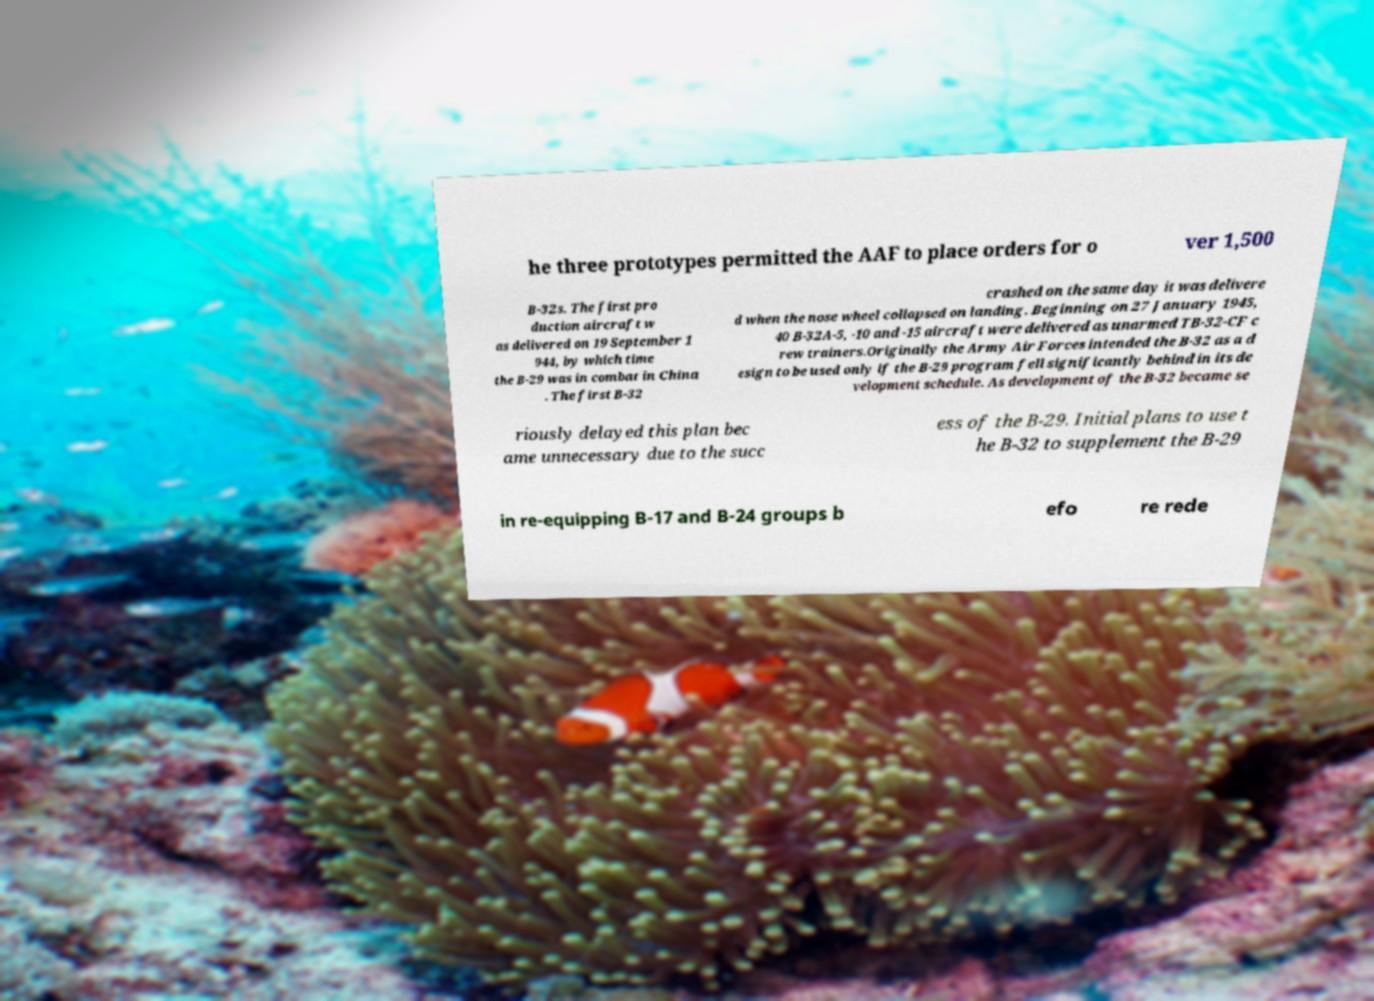There's text embedded in this image that I need extracted. Can you transcribe it verbatim? he three prototypes permitted the AAF to place orders for o ver 1,500 B-32s. The first pro duction aircraft w as delivered on 19 September 1 944, by which time the B-29 was in combat in China . The first B-32 crashed on the same day it was delivere d when the nose wheel collapsed on landing. Beginning on 27 January 1945, 40 B-32A-5, -10 and -15 aircraft were delivered as unarmed TB-32-CF c rew trainers.Originally the Army Air Forces intended the B-32 as a d esign to be used only if the B-29 program fell significantly behind in its de velopment schedule. As development of the B-32 became se riously delayed this plan bec ame unnecessary due to the succ ess of the B-29. Initial plans to use t he B-32 to supplement the B-29 in re-equipping B-17 and B-24 groups b efo re rede 